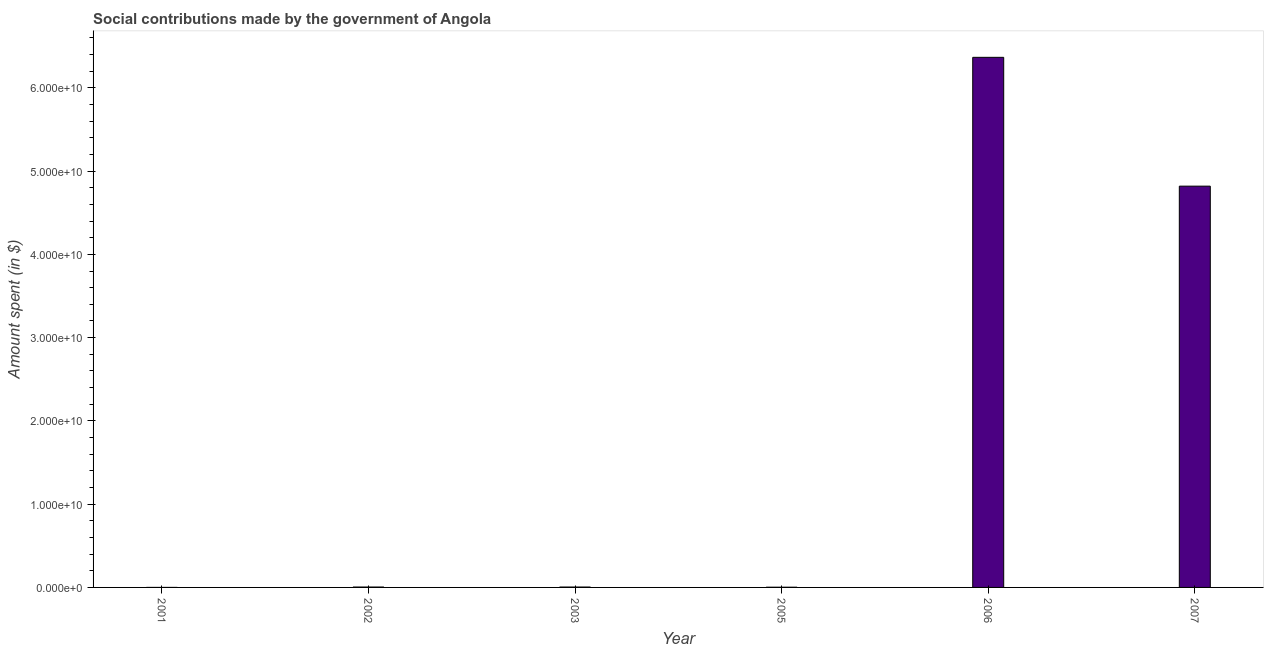Does the graph contain any zero values?
Ensure brevity in your answer.  No. Does the graph contain grids?
Provide a succinct answer. No. What is the title of the graph?
Keep it short and to the point. Social contributions made by the government of Angola. What is the label or title of the X-axis?
Offer a terse response. Year. What is the label or title of the Y-axis?
Provide a short and direct response. Amount spent (in $). What is the amount spent in making social contributions in 2003?
Your response must be concise. 4.62e+07. Across all years, what is the maximum amount spent in making social contributions?
Keep it short and to the point. 6.37e+1. Across all years, what is the minimum amount spent in making social contributions?
Offer a terse response. 4778. In which year was the amount spent in making social contributions maximum?
Make the answer very short. 2006. In which year was the amount spent in making social contributions minimum?
Provide a succinct answer. 2001. What is the sum of the amount spent in making social contributions?
Your answer should be compact. 1.12e+11. What is the difference between the amount spent in making social contributions in 2001 and 2003?
Provide a short and direct response. -4.62e+07. What is the average amount spent in making social contributions per year?
Provide a short and direct response. 1.87e+1. What is the median amount spent in making social contributions?
Provide a succinct answer. 4.65e+07. In how many years, is the amount spent in making social contributions greater than 32000000000 $?
Keep it short and to the point. 2. Do a majority of the years between 2002 and 2001 (inclusive) have amount spent in making social contributions greater than 22000000000 $?
Give a very brief answer. No. What is the ratio of the amount spent in making social contributions in 2003 to that in 2005?
Make the answer very short. 1.88. What is the difference between the highest and the second highest amount spent in making social contributions?
Make the answer very short. 1.55e+1. Is the sum of the amount spent in making social contributions in 2003 and 2006 greater than the maximum amount spent in making social contributions across all years?
Ensure brevity in your answer.  Yes. What is the difference between the highest and the lowest amount spent in making social contributions?
Provide a short and direct response. 6.37e+1. In how many years, is the amount spent in making social contributions greater than the average amount spent in making social contributions taken over all years?
Ensure brevity in your answer.  2. How many bars are there?
Give a very brief answer. 6. What is the Amount spent (in $) of 2001?
Keep it short and to the point. 4778. What is the Amount spent (in $) in 2002?
Provide a succinct answer. 4.68e+07. What is the Amount spent (in $) in 2003?
Your response must be concise. 4.62e+07. What is the Amount spent (in $) in 2005?
Offer a very short reply. 2.46e+07. What is the Amount spent (in $) in 2006?
Provide a succinct answer. 6.37e+1. What is the Amount spent (in $) of 2007?
Make the answer very short. 4.82e+1. What is the difference between the Amount spent (in $) in 2001 and 2002?
Make the answer very short. -4.68e+07. What is the difference between the Amount spent (in $) in 2001 and 2003?
Your response must be concise. -4.62e+07. What is the difference between the Amount spent (in $) in 2001 and 2005?
Offer a terse response. -2.45e+07. What is the difference between the Amount spent (in $) in 2001 and 2006?
Offer a terse response. -6.37e+1. What is the difference between the Amount spent (in $) in 2001 and 2007?
Ensure brevity in your answer.  -4.82e+1. What is the difference between the Amount spent (in $) in 2002 and 2003?
Your response must be concise. 6.53e+05. What is the difference between the Amount spent (in $) in 2002 and 2005?
Your answer should be compact. 2.23e+07. What is the difference between the Amount spent (in $) in 2002 and 2006?
Ensure brevity in your answer.  -6.36e+1. What is the difference between the Amount spent (in $) in 2002 and 2007?
Your response must be concise. -4.81e+1. What is the difference between the Amount spent (in $) in 2003 and 2005?
Keep it short and to the point. 2.16e+07. What is the difference between the Amount spent (in $) in 2003 and 2006?
Offer a terse response. -6.36e+1. What is the difference between the Amount spent (in $) in 2003 and 2007?
Make the answer very short. -4.81e+1. What is the difference between the Amount spent (in $) in 2005 and 2006?
Give a very brief answer. -6.36e+1. What is the difference between the Amount spent (in $) in 2005 and 2007?
Give a very brief answer. -4.82e+1. What is the difference between the Amount spent (in $) in 2006 and 2007?
Offer a terse response. 1.55e+1. What is the ratio of the Amount spent (in $) in 2001 to that in 2002?
Provide a succinct answer. 0. What is the ratio of the Amount spent (in $) in 2001 to that in 2003?
Offer a very short reply. 0. What is the ratio of the Amount spent (in $) in 2001 to that in 2005?
Provide a short and direct response. 0. What is the ratio of the Amount spent (in $) in 2001 to that in 2007?
Your answer should be very brief. 0. What is the ratio of the Amount spent (in $) in 2002 to that in 2005?
Your answer should be compact. 1.91. What is the ratio of the Amount spent (in $) in 2002 to that in 2006?
Offer a terse response. 0. What is the ratio of the Amount spent (in $) in 2002 to that in 2007?
Give a very brief answer. 0. What is the ratio of the Amount spent (in $) in 2003 to that in 2005?
Offer a terse response. 1.88. What is the ratio of the Amount spent (in $) in 2003 to that in 2006?
Your answer should be very brief. 0. What is the ratio of the Amount spent (in $) in 2003 to that in 2007?
Offer a terse response. 0. What is the ratio of the Amount spent (in $) in 2005 to that in 2006?
Your response must be concise. 0. What is the ratio of the Amount spent (in $) in 2006 to that in 2007?
Provide a succinct answer. 1.32. 